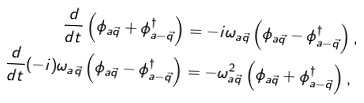<formula> <loc_0><loc_0><loc_500><loc_500>\frac { d } { d t } \left ( \phi _ { a \vec { q } } + \phi _ { a - \vec { q } } ^ { \dagger } \right ) & = - i \omega _ { a \vec { q } } \left ( \phi _ { a \vec { q } } - \phi _ { a - \vec { q } } ^ { \dagger } \right ) , \\ \frac { d } { d t } ( - i ) \omega _ { a \vec { q } } \left ( \phi _ { a \vec { q } } - \phi _ { a - \vec { q } } ^ { \dagger } \right ) & = - \omega _ { a \vec { q } } ^ { 2 } \left ( \phi _ { a \vec { q } } + \phi _ { a - \vec { q } } ^ { \dagger } \right ) ,</formula> 